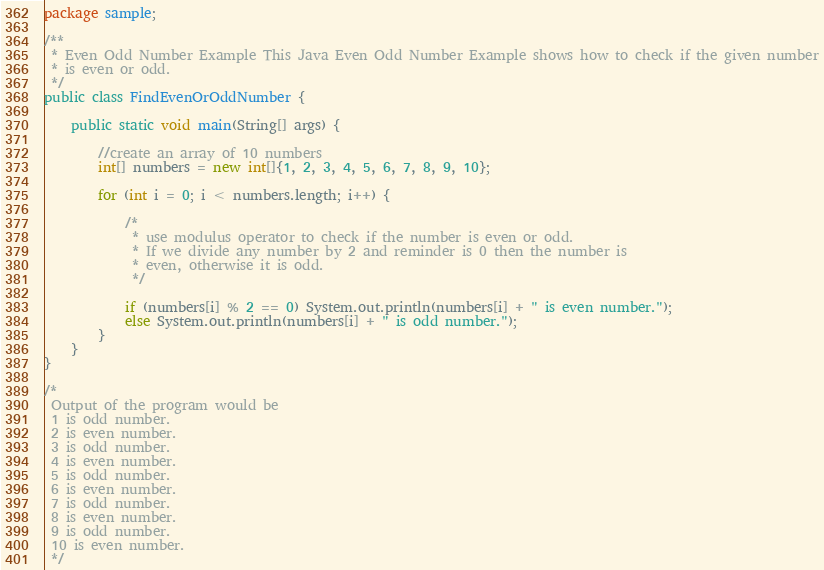Convert code to text. <code><loc_0><loc_0><loc_500><loc_500><_Java_>package sample;

/**
 * Even Odd Number Example This Java Even Odd Number Example shows how to check if the given number
 * is even or odd.
 */
public class FindEvenOrOddNumber {

    public static void main(String[] args) {

        //create an array of 10 numbers
        int[] numbers = new int[]{1, 2, 3, 4, 5, 6, 7, 8, 9, 10};

        for (int i = 0; i < numbers.length; i++) {

            /*
             * use modulus operator to check if the number is even or odd.
             * If we divide any number by 2 and reminder is 0 then the number is
             * even, otherwise it is odd.
             */

            if (numbers[i] % 2 == 0) System.out.println(numbers[i] + " is even number.");
            else System.out.println(numbers[i] + " is odd number.");
        }
    }
}

/*
 Output of the program would be
 1 is odd number.
 2 is even number.
 3 is odd number.
 4 is even number.
 5 is odd number.
 6 is even number.
 7 is odd number.
 8 is even number.
 9 is odd number.
 10 is even number.
 */
</code> 